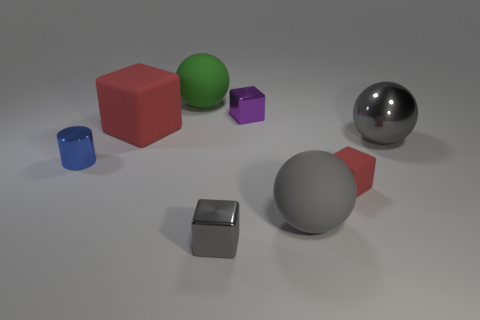What is the size of the gray shiny ball?
Provide a short and direct response. Large. There is a red thing on the right side of the purple metal block; what is its shape?
Your answer should be very brief. Cube. What material is the ball that is left of the big matte ball that is in front of the big green matte ball?
Your answer should be compact. Rubber. Is there a large rubber object of the same color as the tiny rubber object?
Give a very brief answer. Yes. Is the size of the purple block the same as the gray thing on the left side of the small purple thing?
Offer a very short reply. Yes. There is a tiny thing to the right of the big gray ball that is in front of the metal cylinder; what number of green rubber spheres are on the right side of it?
Make the answer very short. 0. How many green objects are right of the purple object?
Your answer should be very brief. 0. The metallic block behind the gray ball that is behind the cylinder is what color?
Ensure brevity in your answer.  Purple. What number of other things are the same material as the large cube?
Provide a succinct answer. 3. Are there an equal number of big gray rubber things that are behind the tiny red matte cube and tiny green matte cylinders?
Offer a terse response. Yes. 